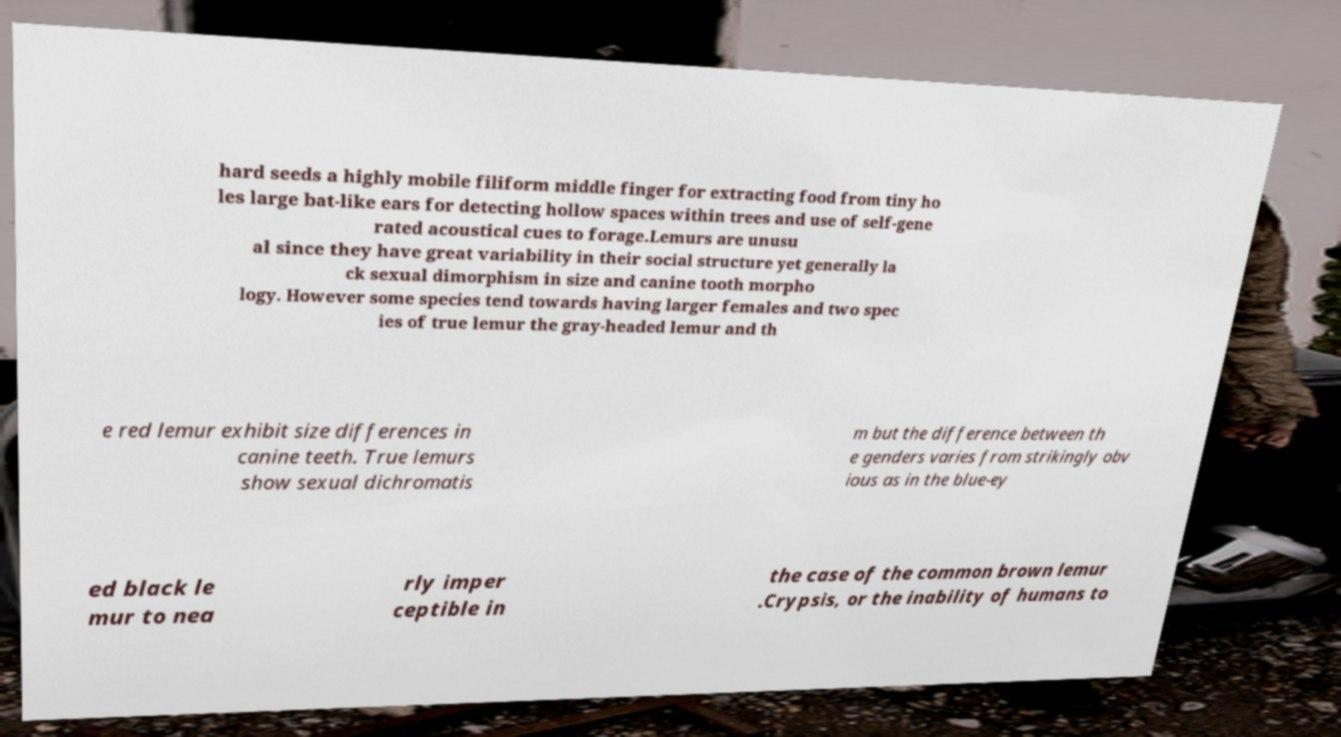Can you accurately transcribe the text from the provided image for me? hard seeds a highly mobile filiform middle finger for extracting food from tiny ho les large bat-like ears for detecting hollow spaces within trees and use of self-gene rated acoustical cues to forage.Lemurs are unusu al since they have great variability in their social structure yet generally la ck sexual dimorphism in size and canine tooth morpho logy. However some species tend towards having larger females and two spec ies of true lemur the gray-headed lemur and th e red lemur exhibit size differences in canine teeth. True lemurs show sexual dichromatis m but the difference between th e genders varies from strikingly obv ious as in the blue-ey ed black le mur to nea rly imper ceptible in the case of the common brown lemur .Crypsis, or the inability of humans to 